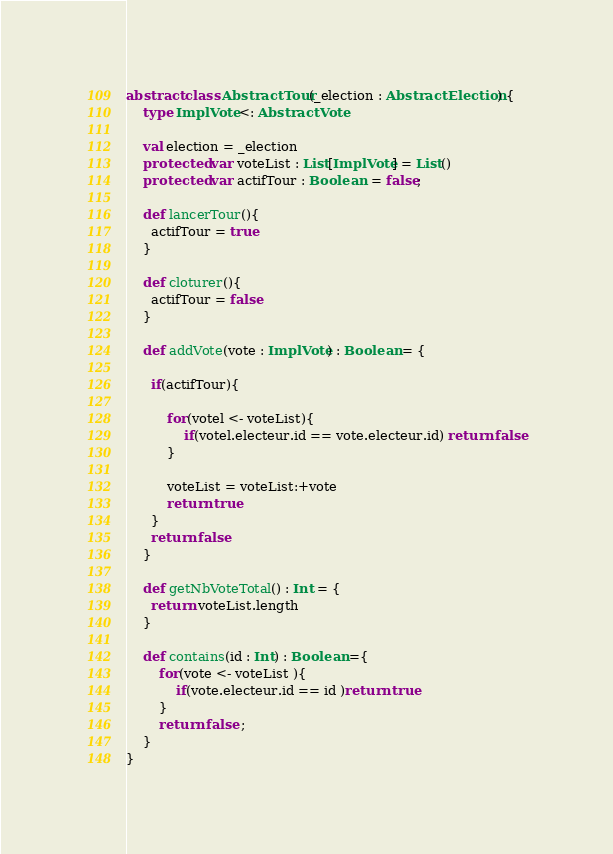<code> <loc_0><loc_0><loc_500><loc_500><_Scala_>abstract class AbstractTour(_election : AbstractElection) {
	type ImplVote <: AbstractVote
  
	val election = _election
	protected var voteList : List[ImplVote] = List()
	protected var actifTour : Boolean  = false;
	
	def lancerTour(){
	  actifTour = true
	}
	
	def cloturer(){
	  actifTour = false
	}
	
	def addVote(vote : ImplVote) : Boolean = {
	  
	  if(actifTour){
		  
	      for(votel <- voteList){
			  if(votel.electeur.id == vote.electeur.id) return false
		  }
		  
	      voteList = voteList:+vote
		  return true
	  }
	  return false
	}
	
	def getNbVoteTotal() : Int = {
	  return voteList.length
	}
	
	def contains(id : Int) : Boolean ={
		for(vote <- voteList ){
			if(vote.electeur.id == id )return true
		}
		return false ;
	}
}</code> 